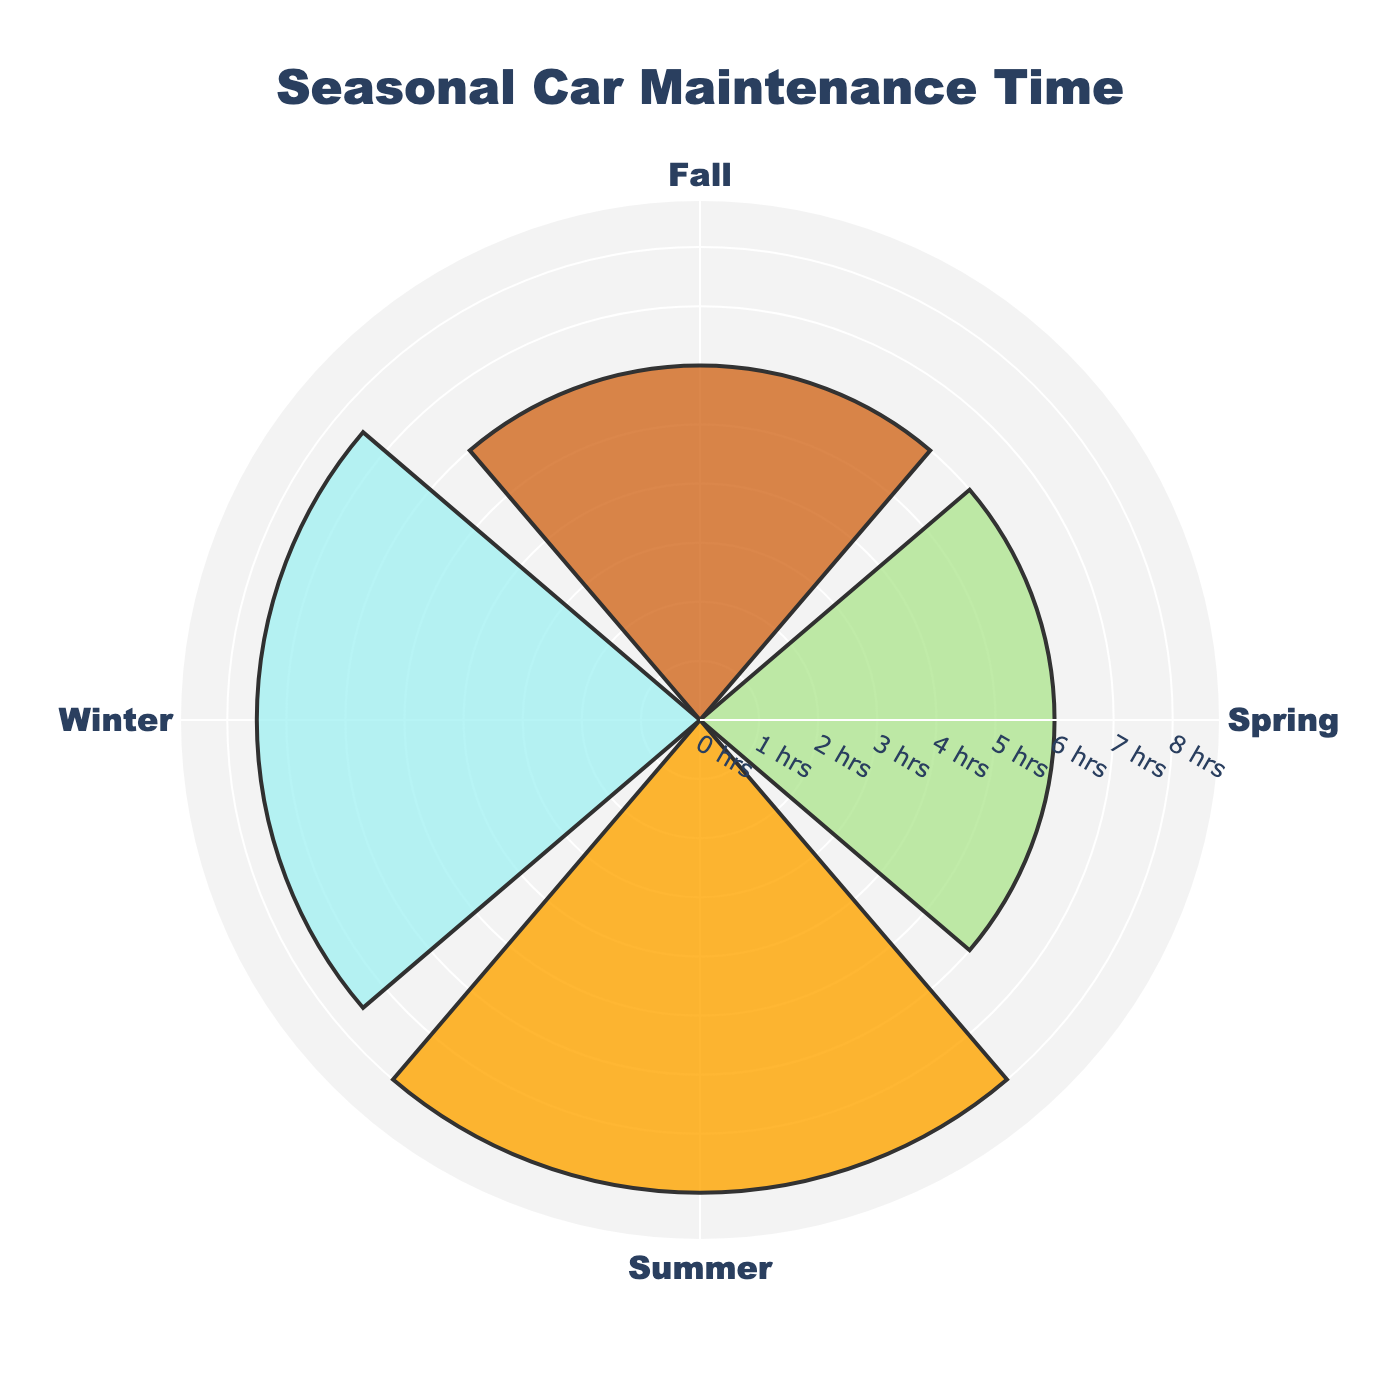What is the title of the figure? The figure's title can be found at the top of the chart, typically centered. In this case, the title provides an overview of the data presented.
Answer: Seasonal Car Maintenance Time Which season has the longest total maintenance time? To find the season with the longest total maintenance time, look at the lengths of the bars in the rose chart. The season with the longest bar has the highest total time.
Answer: Summer How many hours were spent on car maintenance in the Winter? Look at the radial value for Winter in the rose chart. The bar length indicates the total hours spent on Winter maintenance.
Answer: 7.5 hours What color represents Spring? Observe the rose chart and identify the color used for the sector labeled 'Spring.' In this chart, each season is color-coded distinctively.
Answer: Green Which two seasons have the same total maintenance time? Compare the lengths of the bars for each season. The bars with equal lengths represent seasons with the same total maintenance time.
Answer: Spring and Fall By how many hours does the total maintenance time in Summer exceed that of Winter? First, note the total hours for Summer and Winter, which are 8 hours and 7.5 hours, respectively. Subtract the Winter total from the Summer total to find the difference.
Answer: 0.5 hours If we combine the total maintenance times of Spring and Fall, what is their sum? Sum the total hours spent on Spring and Fall maintenance. Both Spring and Fall have total times of 6 hours each.
Answer: 12 hours Which season has the least total maintenance time, and how much is it? Identify the shortest bar in the rose chart, which represents the season with the least maintenance time. Note the corresponding value.
Answer: Spring, 6 hours What is the average maintenance time across all seasons? Sum the total maintenance times for all four seasons: Winter (7.5), Spring (6), Summer (8), and Fall (6). The sum is 27.5. Divide this by the number of seasons (4) to find the average.
Answer: 6.875 hours Compare the car maintenance time between Spring and Fall. Which season has more maintenance activities, or are they equal? Look at the lengths of the bars for Spring and Fall. If the bars are of equal length, the seasons have the same maintenance time.
Answer: They are equal 